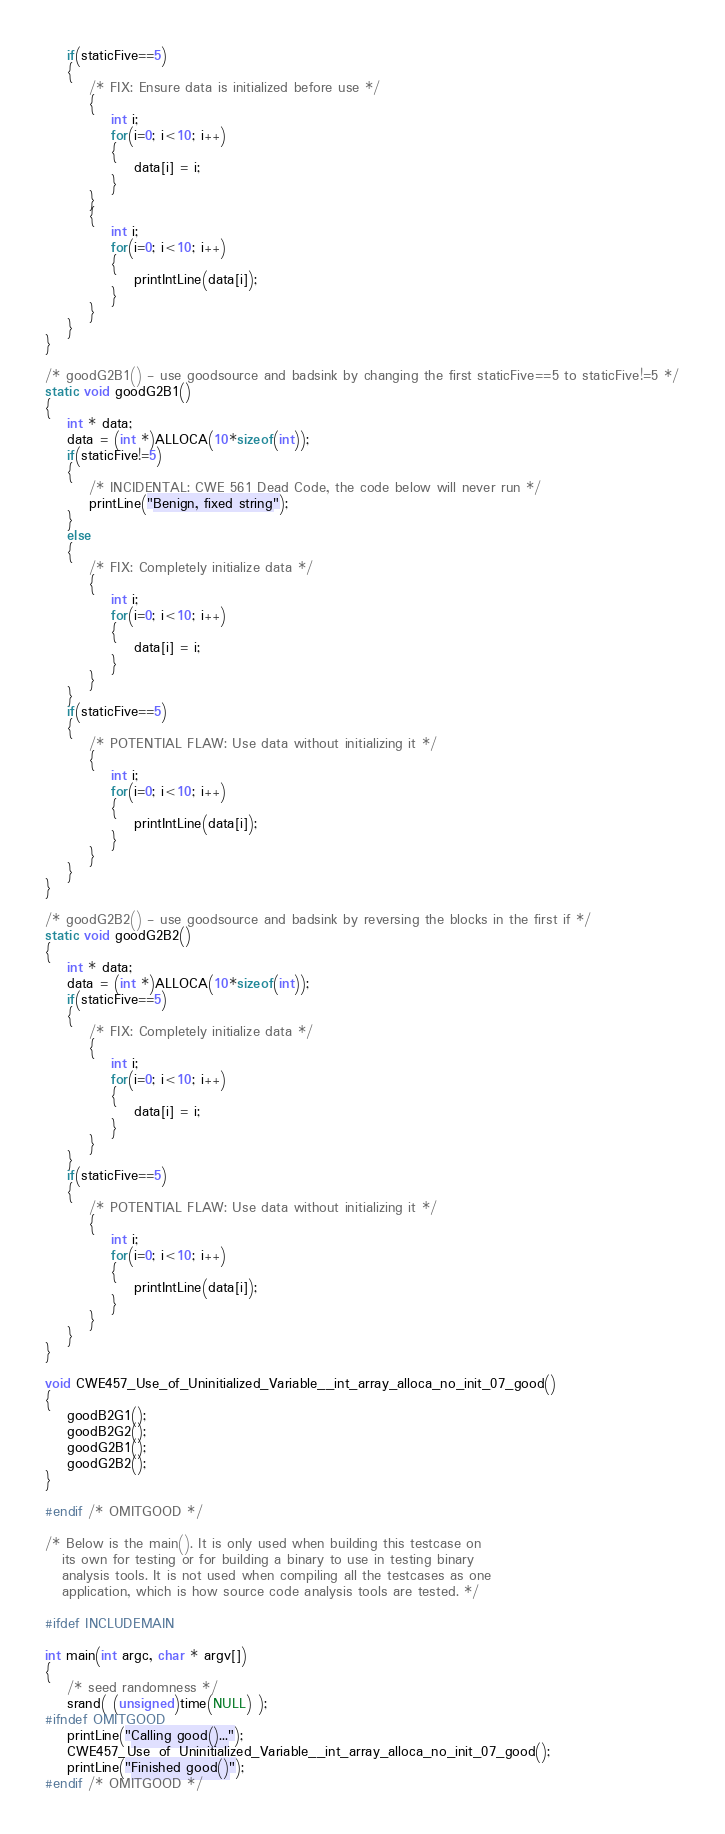<code> <loc_0><loc_0><loc_500><loc_500><_C_>    if(staticFive==5)
    {
        /* FIX: Ensure data is initialized before use */
        {
            int i;
            for(i=0; i<10; i++)
            {
                data[i] = i;
            }
        }
        {
            int i;
            for(i=0; i<10; i++)
            {
                printIntLine(data[i]);
            }
        }
    }
}

/* goodG2B1() - use goodsource and badsink by changing the first staticFive==5 to staticFive!=5 */
static void goodG2B1()
{
    int * data;
    data = (int *)ALLOCA(10*sizeof(int));
    if(staticFive!=5)
    {
        /* INCIDENTAL: CWE 561 Dead Code, the code below will never run */
        printLine("Benign, fixed string");
    }
    else
    {
        /* FIX: Completely initialize data */
        {
            int i;
            for(i=0; i<10; i++)
            {
                data[i] = i;
            }
        }
    }
    if(staticFive==5)
    {
        /* POTENTIAL FLAW: Use data without initializing it */
        {
            int i;
            for(i=0; i<10; i++)
            {
                printIntLine(data[i]);
            }
        }
    }
}

/* goodG2B2() - use goodsource and badsink by reversing the blocks in the first if */
static void goodG2B2()
{
    int * data;
    data = (int *)ALLOCA(10*sizeof(int));
    if(staticFive==5)
    {
        /* FIX: Completely initialize data */
        {
            int i;
            for(i=0; i<10; i++)
            {
                data[i] = i;
            }
        }
    }
    if(staticFive==5)
    {
        /* POTENTIAL FLAW: Use data without initializing it */
        {
            int i;
            for(i=0; i<10; i++)
            {
                printIntLine(data[i]);
            }
        }
    }
}

void CWE457_Use_of_Uninitialized_Variable__int_array_alloca_no_init_07_good()
{
    goodB2G1();
    goodB2G2();
    goodG2B1();
    goodG2B2();
}

#endif /* OMITGOOD */

/* Below is the main(). It is only used when building this testcase on
   its own for testing or for building a binary to use in testing binary
   analysis tools. It is not used when compiling all the testcases as one
   application, which is how source code analysis tools are tested. */

#ifdef INCLUDEMAIN

int main(int argc, char * argv[])
{
    /* seed randomness */
    srand( (unsigned)time(NULL) );
#ifndef OMITGOOD
    printLine("Calling good()...");
    CWE457_Use_of_Uninitialized_Variable__int_array_alloca_no_init_07_good();
    printLine("Finished good()");
#endif /* OMITGOOD */</code> 